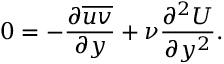<formula> <loc_0><loc_0><loc_500><loc_500>0 = - \frac { \partial { \overline { u v } } } { \partial { y } } + \nu \frac { \partial ^ { 2 } U } { \partial y ^ { 2 } } .</formula> 